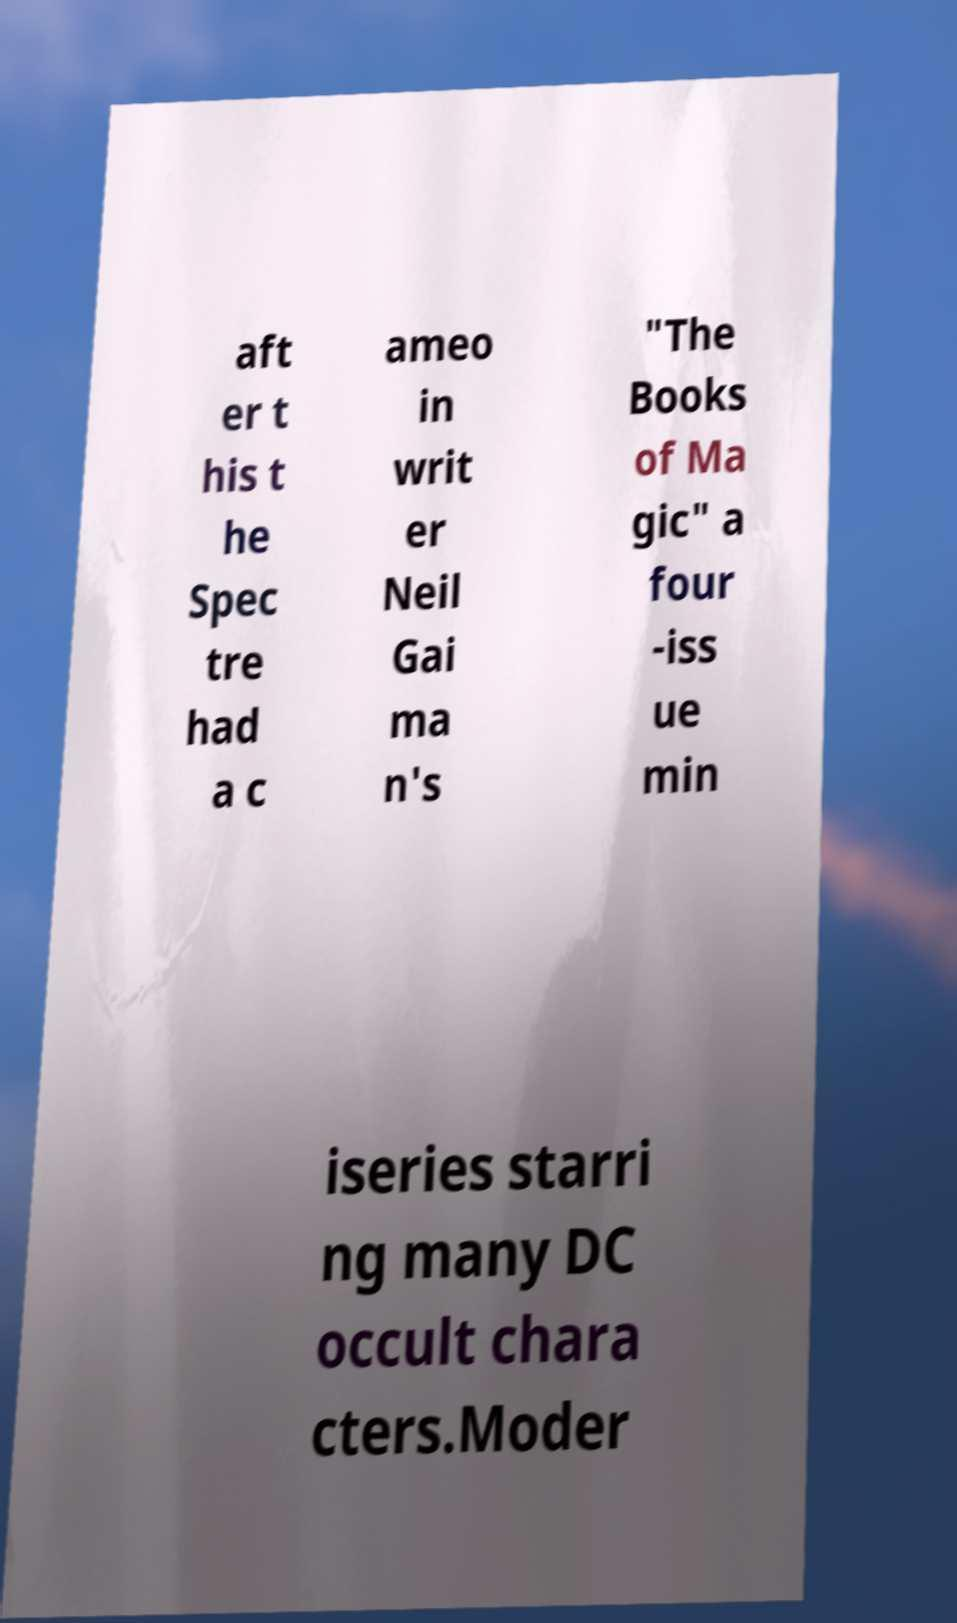Could you extract and type out the text from this image? aft er t his t he Spec tre had a c ameo in writ er Neil Gai ma n's "The Books of Ma gic" a four -iss ue min iseries starri ng many DC occult chara cters.Moder 